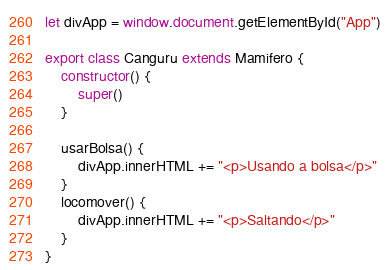<code> <loc_0><loc_0><loc_500><loc_500><_JavaScript_>let divApp = window.document.getElementById("App")

export class Canguru extends Mamifero {
    constructor() {
        super()
    }

    usarBolsa() {
        divApp.innerHTML += "<p>Usando a bolsa</p>"
    }
    locomover() {
        divApp.innerHTML += "<p>Saltando</p>"
    }
}</code> 